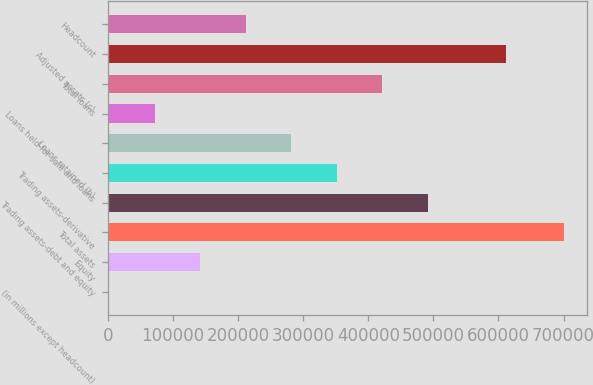<chart> <loc_0><loc_0><loc_500><loc_500><bar_chart><fcel>(in millions except headcount)<fcel>Equity<fcel>Total assets<fcel>Trading assets-debt and equity<fcel>Trading assets-derivative<fcel>Loans retained (b)<fcel>Loans held-for-sale and loans<fcel>Total loans<fcel>Adjusted assets (c)<fcel>Headcount<nl><fcel>2007<fcel>141719<fcel>700565<fcel>490998<fcel>351286<fcel>281430<fcel>71862.8<fcel>421142<fcel>611749<fcel>211574<nl></chart> 